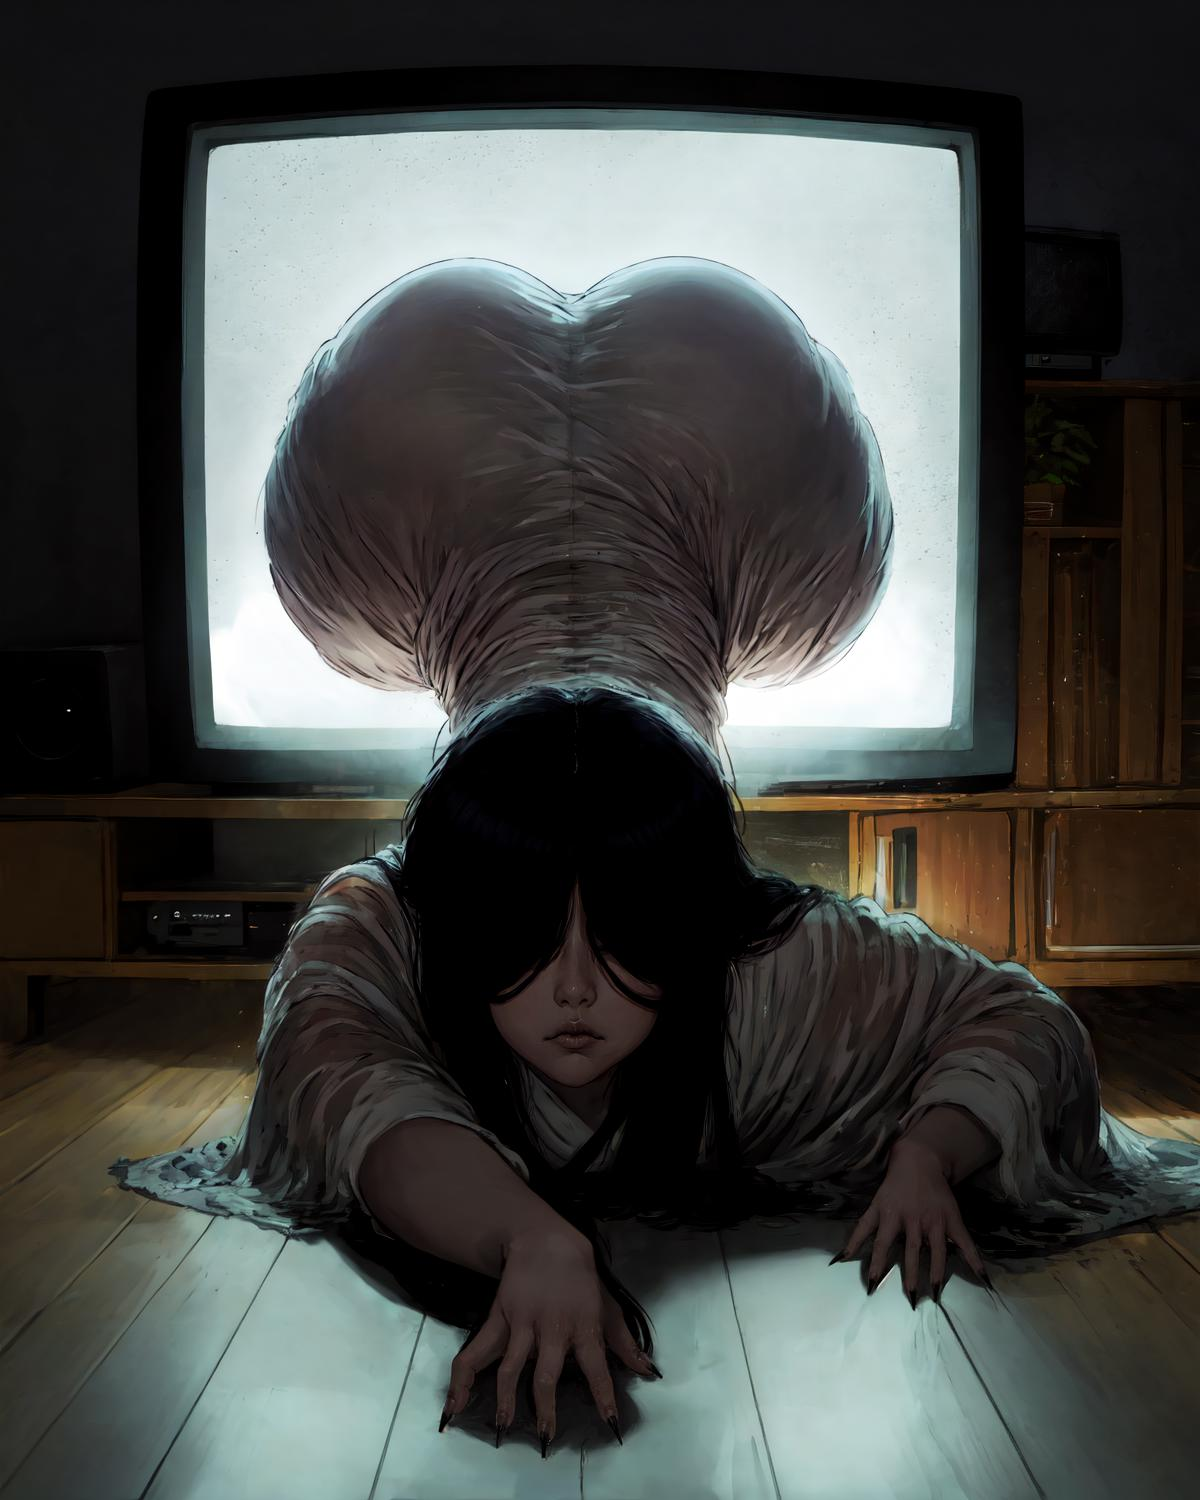describe this image The image depicts a woman with long black hair crawling towards the viewer. Her body is bent unnaturally, as if she is emerging from the television screen. Her face is obscured by her hair, but her eyes are visible, staring directly at the viewer. The woman is wearing a white dress that is torn and tattered, giving the impression that she is a ghost. The television screen is lit up behind her, casting a warm glow on the scene. The overall effect of the image is one of unease and horror. It suggests that the woman is a supernatural being who has crossed over into the real world. 